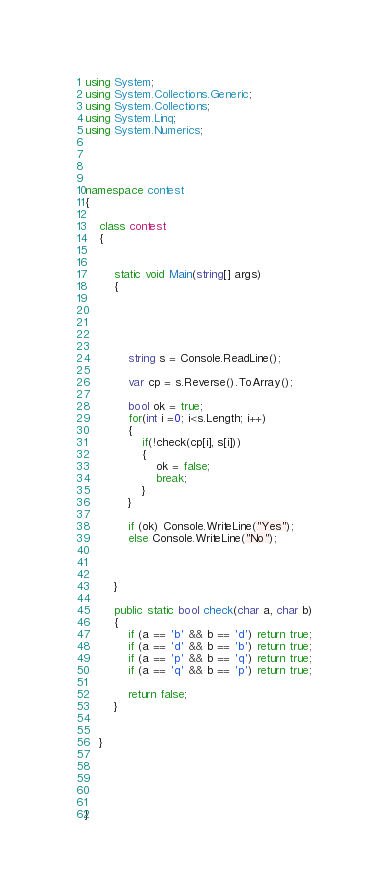Convert code to text. <code><loc_0><loc_0><loc_500><loc_500><_C#_>using System;
using System.Collections.Generic;
using System.Collections;
using System.Linq;
using System.Numerics;




namespace contest
{

    class contest
    {


        static void Main(string[] args)
        {


      


            string s = Console.ReadLine();

            var cp = s.Reverse().ToArray();

            bool ok = true;
            for(int i =0; i<s.Length; i++)
            {
                if(!check(cp[i], s[i]))
                {
                    ok = false;
                    break;
                }
            }

            if (ok) Console.WriteLine("Yes");
            else Console.WriteLine("No");



        }

		public static bool check(char a, char b)
        {
            if (a == 'b' && b == 'd') return true;
            if (a == 'd' && b == 'b') return true;
            if (a == 'p' && b == 'q') return true;
            if (a == 'q' && b == 'p') return true;
            
            return false;
        }
        

    }


   

    
}
</code> 